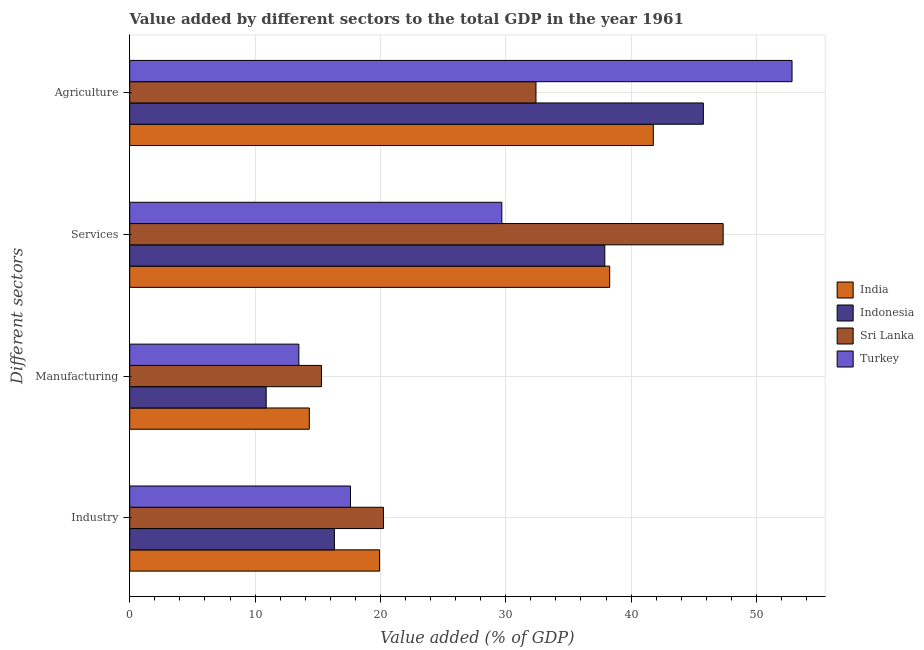Are the number of bars per tick equal to the number of legend labels?
Make the answer very short. Yes. How many bars are there on the 1st tick from the top?
Keep it short and to the point. 4. What is the label of the 4th group of bars from the top?
Your answer should be very brief. Industry. What is the value added by agricultural sector in Turkey?
Your answer should be very brief. 52.84. Across all countries, what is the maximum value added by industrial sector?
Offer a very short reply. 20.24. Across all countries, what is the minimum value added by services sector?
Your answer should be very brief. 29.69. In which country was the value added by manufacturing sector maximum?
Your response must be concise. Sri Lanka. In which country was the value added by agricultural sector minimum?
Provide a short and direct response. Sri Lanka. What is the total value added by services sector in the graph?
Your answer should be very brief. 153.23. What is the difference between the value added by services sector in Indonesia and that in India?
Provide a succinct answer. -0.39. What is the difference between the value added by manufacturing sector in Sri Lanka and the value added by industrial sector in India?
Keep it short and to the point. -4.64. What is the average value added by manufacturing sector per country?
Your response must be concise. 13.5. What is the difference between the value added by manufacturing sector and value added by services sector in India?
Make the answer very short. -23.96. What is the ratio of the value added by industrial sector in Indonesia to that in Turkey?
Offer a very short reply. 0.93. Is the value added by manufacturing sector in Turkey less than that in India?
Give a very brief answer. Yes. Is the difference between the value added by agricultural sector in Indonesia and India greater than the difference between the value added by industrial sector in Indonesia and India?
Ensure brevity in your answer.  Yes. What is the difference between the highest and the second highest value added by services sector?
Your answer should be compact. 9.05. What is the difference between the highest and the lowest value added by industrial sector?
Your answer should be very brief. 3.91. Is the sum of the value added by services sector in Turkey and Indonesia greater than the maximum value added by agricultural sector across all countries?
Your answer should be compact. Yes. What does the 1st bar from the bottom in Manufacturing represents?
Your answer should be very brief. India. How many countries are there in the graph?
Offer a very short reply. 4. Are the values on the major ticks of X-axis written in scientific E-notation?
Offer a terse response. No. Does the graph contain any zero values?
Make the answer very short. No. Does the graph contain grids?
Provide a short and direct response. Yes. How many legend labels are there?
Make the answer very short. 4. What is the title of the graph?
Your answer should be compact. Value added by different sectors to the total GDP in the year 1961. Does "New Caledonia" appear as one of the legend labels in the graph?
Offer a very short reply. No. What is the label or title of the X-axis?
Provide a succinct answer. Value added (% of GDP). What is the label or title of the Y-axis?
Your answer should be compact. Different sectors. What is the Value added (% of GDP) in India in Industry?
Keep it short and to the point. 19.93. What is the Value added (% of GDP) of Indonesia in Industry?
Your response must be concise. 16.33. What is the Value added (% of GDP) in Sri Lanka in Industry?
Keep it short and to the point. 20.24. What is the Value added (% of GDP) of Turkey in Industry?
Make the answer very short. 17.61. What is the Value added (% of GDP) of India in Manufacturing?
Your answer should be very brief. 14.33. What is the Value added (% of GDP) of Indonesia in Manufacturing?
Make the answer very short. 10.89. What is the Value added (% of GDP) of Sri Lanka in Manufacturing?
Provide a succinct answer. 15.3. What is the Value added (% of GDP) of Turkey in Manufacturing?
Make the answer very short. 13.49. What is the Value added (% of GDP) of India in Services?
Provide a short and direct response. 38.29. What is the Value added (% of GDP) of Indonesia in Services?
Your response must be concise. 37.9. What is the Value added (% of GDP) in Sri Lanka in Services?
Offer a very short reply. 47.35. What is the Value added (% of GDP) of Turkey in Services?
Your answer should be compact. 29.69. What is the Value added (% of GDP) in India in Agriculture?
Provide a succinct answer. 41.77. What is the Value added (% of GDP) in Indonesia in Agriculture?
Provide a succinct answer. 45.77. What is the Value added (% of GDP) of Sri Lanka in Agriculture?
Your answer should be compact. 32.41. What is the Value added (% of GDP) in Turkey in Agriculture?
Provide a short and direct response. 52.84. Across all Different sectors, what is the maximum Value added (% of GDP) of India?
Offer a very short reply. 41.77. Across all Different sectors, what is the maximum Value added (% of GDP) of Indonesia?
Offer a terse response. 45.77. Across all Different sectors, what is the maximum Value added (% of GDP) in Sri Lanka?
Offer a terse response. 47.35. Across all Different sectors, what is the maximum Value added (% of GDP) in Turkey?
Your answer should be very brief. 52.84. Across all Different sectors, what is the minimum Value added (% of GDP) in India?
Provide a short and direct response. 14.33. Across all Different sectors, what is the minimum Value added (% of GDP) in Indonesia?
Your answer should be very brief. 10.89. Across all Different sectors, what is the minimum Value added (% of GDP) of Sri Lanka?
Your answer should be compact. 15.3. Across all Different sectors, what is the minimum Value added (% of GDP) in Turkey?
Keep it short and to the point. 13.49. What is the total Value added (% of GDP) of India in the graph?
Ensure brevity in your answer.  114.33. What is the total Value added (% of GDP) of Indonesia in the graph?
Provide a short and direct response. 110.89. What is the total Value added (% of GDP) of Sri Lanka in the graph?
Offer a very short reply. 115.3. What is the total Value added (% of GDP) of Turkey in the graph?
Provide a short and direct response. 113.64. What is the difference between the Value added (% of GDP) of India in Industry and that in Manufacturing?
Make the answer very short. 5.61. What is the difference between the Value added (% of GDP) in Indonesia in Industry and that in Manufacturing?
Your answer should be very brief. 5.44. What is the difference between the Value added (% of GDP) of Sri Lanka in Industry and that in Manufacturing?
Your response must be concise. 4.95. What is the difference between the Value added (% of GDP) in Turkey in Industry and that in Manufacturing?
Offer a terse response. 4.12. What is the difference between the Value added (% of GDP) of India in Industry and that in Services?
Your answer should be compact. -18.36. What is the difference between the Value added (% of GDP) of Indonesia in Industry and that in Services?
Provide a succinct answer. -21.57. What is the difference between the Value added (% of GDP) in Sri Lanka in Industry and that in Services?
Offer a very short reply. -27.1. What is the difference between the Value added (% of GDP) in Turkey in Industry and that in Services?
Offer a terse response. -12.07. What is the difference between the Value added (% of GDP) in India in Industry and that in Agriculture?
Provide a succinct answer. -21.84. What is the difference between the Value added (% of GDP) of Indonesia in Industry and that in Agriculture?
Make the answer very short. -29.44. What is the difference between the Value added (% of GDP) of Sri Lanka in Industry and that in Agriculture?
Your answer should be very brief. -12.17. What is the difference between the Value added (% of GDP) in Turkey in Industry and that in Agriculture?
Your response must be concise. -35.23. What is the difference between the Value added (% of GDP) of India in Manufacturing and that in Services?
Your answer should be very brief. -23.96. What is the difference between the Value added (% of GDP) in Indonesia in Manufacturing and that in Services?
Provide a short and direct response. -27.02. What is the difference between the Value added (% of GDP) in Sri Lanka in Manufacturing and that in Services?
Offer a terse response. -32.05. What is the difference between the Value added (% of GDP) of Turkey in Manufacturing and that in Services?
Your answer should be compact. -16.19. What is the difference between the Value added (% of GDP) in India in Manufacturing and that in Agriculture?
Your answer should be very brief. -27.45. What is the difference between the Value added (% of GDP) in Indonesia in Manufacturing and that in Agriculture?
Provide a succinct answer. -34.88. What is the difference between the Value added (% of GDP) of Sri Lanka in Manufacturing and that in Agriculture?
Make the answer very short. -17.11. What is the difference between the Value added (% of GDP) in Turkey in Manufacturing and that in Agriculture?
Ensure brevity in your answer.  -39.35. What is the difference between the Value added (% of GDP) of India in Services and that in Agriculture?
Your response must be concise. -3.48. What is the difference between the Value added (% of GDP) in Indonesia in Services and that in Agriculture?
Keep it short and to the point. -7.86. What is the difference between the Value added (% of GDP) of Sri Lanka in Services and that in Agriculture?
Your response must be concise. 14.93. What is the difference between the Value added (% of GDP) of Turkey in Services and that in Agriculture?
Keep it short and to the point. -23.15. What is the difference between the Value added (% of GDP) of India in Industry and the Value added (% of GDP) of Indonesia in Manufacturing?
Make the answer very short. 9.05. What is the difference between the Value added (% of GDP) of India in Industry and the Value added (% of GDP) of Sri Lanka in Manufacturing?
Keep it short and to the point. 4.64. What is the difference between the Value added (% of GDP) of India in Industry and the Value added (% of GDP) of Turkey in Manufacturing?
Your answer should be very brief. 6.44. What is the difference between the Value added (% of GDP) of Indonesia in Industry and the Value added (% of GDP) of Sri Lanka in Manufacturing?
Provide a short and direct response. 1.03. What is the difference between the Value added (% of GDP) in Indonesia in Industry and the Value added (% of GDP) in Turkey in Manufacturing?
Provide a succinct answer. 2.84. What is the difference between the Value added (% of GDP) of Sri Lanka in Industry and the Value added (% of GDP) of Turkey in Manufacturing?
Offer a terse response. 6.75. What is the difference between the Value added (% of GDP) of India in Industry and the Value added (% of GDP) of Indonesia in Services?
Provide a succinct answer. -17.97. What is the difference between the Value added (% of GDP) of India in Industry and the Value added (% of GDP) of Sri Lanka in Services?
Make the answer very short. -27.41. What is the difference between the Value added (% of GDP) in India in Industry and the Value added (% of GDP) in Turkey in Services?
Offer a very short reply. -9.75. What is the difference between the Value added (% of GDP) of Indonesia in Industry and the Value added (% of GDP) of Sri Lanka in Services?
Your answer should be compact. -31.02. What is the difference between the Value added (% of GDP) of Indonesia in Industry and the Value added (% of GDP) of Turkey in Services?
Ensure brevity in your answer.  -13.36. What is the difference between the Value added (% of GDP) of Sri Lanka in Industry and the Value added (% of GDP) of Turkey in Services?
Offer a terse response. -9.44. What is the difference between the Value added (% of GDP) in India in Industry and the Value added (% of GDP) in Indonesia in Agriculture?
Give a very brief answer. -25.83. What is the difference between the Value added (% of GDP) in India in Industry and the Value added (% of GDP) in Sri Lanka in Agriculture?
Make the answer very short. -12.48. What is the difference between the Value added (% of GDP) in India in Industry and the Value added (% of GDP) in Turkey in Agriculture?
Offer a terse response. -32.91. What is the difference between the Value added (% of GDP) in Indonesia in Industry and the Value added (% of GDP) in Sri Lanka in Agriculture?
Give a very brief answer. -16.08. What is the difference between the Value added (% of GDP) of Indonesia in Industry and the Value added (% of GDP) of Turkey in Agriculture?
Provide a succinct answer. -36.51. What is the difference between the Value added (% of GDP) of Sri Lanka in Industry and the Value added (% of GDP) of Turkey in Agriculture?
Your response must be concise. -32.6. What is the difference between the Value added (% of GDP) of India in Manufacturing and the Value added (% of GDP) of Indonesia in Services?
Offer a very short reply. -23.58. What is the difference between the Value added (% of GDP) of India in Manufacturing and the Value added (% of GDP) of Sri Lanka in Services?
Your answer should be very brief. -33.02. What is the difference between the Value added (% of GDP) of India in Manufacturing and the Value added (% of GDP) of Turkey in Services?
Offer a very short reply. -15.36. What is the difference between the Value added (% of GDP) in Indonesia in Manufacturing and the Value added (% of GDP) in Sri Lanka in Services?
Your response must be concise. -36.46. What is the difference between the Value added (% of GDP) of Indonesia in Manufacturing and the Value added (% of GDP) of Turkey in Services?
Offer a very short reply. -18.8. What is the difference between the Value added (% of GDP) of Sri Lanka in Manufacturing and the Value added (% of GDP) of Turkey in Services?
Your answer should be very brief. -14.39. What is the difference between the Value added (% of GDP) of India in Manufacturing and the Value added (% of GDP) of Indonesia in Agriculture?
Give a very brief answer. -31.44. What is the difference between the Value added (% of GDP) of India in Manufacturing and the Value added (% of GDP) of Sri Lanka in Agriculture?
Offer a terse response. -18.08. What is the difference between the Value added (% of GDP) in India in Manufacturing and the Value added (% of GDP) in Turkey in Agriculture?
Offer a very short reply. -38.51. What is the difference between the Value added (% of GDP) in Indonesia in Manufacturing and the Value added (% of GDP) in Sri Lanka in Agriculture?
Your answer should be very brief. -21.52. What is the difference between the Value added (% of GDP) of Indonesia in Manufacturing and the Value added (% of GDP) of Turkey in Agriculture?
Offer a terse response. -41.95. What is the difference between the Value added (% of GDP) of Sri Lanka in Manufacturing and the Value added (% of GDP) of Turkey in Agriculture?
Provide a succinct answer. -37.54. What is the difference between the Value added (% of GDP) of India in Services and the Value added (% of GDP) of Indonesia in Agriculture?
Offer a very short reply. -7.47. What is the difference between the Value added (% of GDP) of India in Services and the Value added (% of GDP) of Sri Lanka in Agriculture?
Your answer should be very brief. 5.88. What is the difference between the Value added (% of GDP) of India in Services and the Value added (% of GDP) of Turkey in Agriculture?
Provide a succinct answer. -14.55. What is the difference between the Value added (% of GDP) in Indonesia in Services and the Value added (% of GDP) in Sri Lanka in Agriculture?
Your answer should be compact. 5.49. What is the difference between the Value added (% of GDP) of Indonesia in Services and the Value added (% of GDP) of Turkey in Agriculture?
Ensure brevity in your answer.  -14.94. What is the difference between the Value added (% of GDP) of Sri Lanka in Services and the Value added (% of GDP) of Turkey in Agriculture?
Offer a terse response. -5.5. What is the average Value added (% of GDP) in India per Different sectors?
Keep it short and to the point. 28.58. What is the average Value added (% of GDP) of Indonesia per Different sectors?
Make the answer very short. 27.72. What is the average Value added (% of GDP) of Sri Lanka per Different sectors?
Give a very brief answer. 28.82. What is the average Value added (% of GDP) in Turkey per Different sectors?
Keep it short and to the point. 28.41. What is the difference between the Value added (% of GDP) of India and Value added (% of GDP) of Indonesia in Industry?
Your answer should be very brief. 3.6. What is the difference between the Value added (% of GDP) of India and Value added (% of GDP) of Sri Lanka in Industry?
Your answer should be compact. -0.31. What is the difference between the Value added (% of GDP) in India and Value added (% of GDP) in Turkey in Industry?
Give a very brief answer. 2.32. What is the difference between the Value added (% of GDP) of Indonesia and Value added (% of GDP) of Sri Lanka in Industry?
Offer a very short reply. -3.91. What is the difference between the Value added (% of GDP) in Indonesia and Value added (% of GDP) in Turkey in Industry?
Your answer should be very brief. -1.28. What is the difference between the Value added (% of GDP) of Sri Lanka and Value added (% of GDP) of Turkey in Industry?
Your answer should be compact. 2.63. What is the difference between the Value added (% of GDP) in India and Value added (% of GDP) in Indonesia in Manufacturing?
Ensure brevity in your answer.  3.44. What is the difference between the Value added (% of GDP) of India and Value added (% of GDP) of Sri Lanka in Manufacturing?
Give a very brief answer. -0.97. What is the difference between the Value added (% of GDP) in India and Value added (% of GDP) in Turkey in Manufacturing?
Ensure brevity in your answer.  0.83. What is the difference between the Value added (% of GDP) in Indonesia and Value added (% of GDP) in Sri Lanka in Manufacturing?
Offer a very short reply. -4.41. What is the difference between the Value added (% of GDP) in Indonesia and Value added (% of GDP) in Turkey in Manufacturing?
Your answer should be compact. -2.61. What is the difference between the Value added (% of GDP) in Sri Lanka and Value added (% of GDP) in Turkey in Manufacturing?
Your answer should be very brief. 1.8. What is the difference between the Value added (% of GDP) in India and Value added (% of GDP) in Indonesia in Services?
Give a very brief answer. 0.39. What is the difference between the Value added (% of GDP) in India and Value added (% of GDP) in Sri Lanka in Services?
Ensure brevity in your answer.  -9.05. What is the difference between the Value added (% of GDP) of India and Value added (% of GDP) of Turkey in Services?
Provide a short and direct response. 8.61. What is the difference between the Value added (% of GDP) in Indonesia and Value added (% of GDP) in Sri Lanka in Services?
Provide a short and direct response. -9.44. What is the difference between the Value added (% of GDP) of Indonesia and Value added (% of GDP) of Turkey in Services?
Your answer should be compact. 8.22. What is the difference between the Value added (% of GDP) in Sri Lanka and Value added (% of GDP) in Turkey in Services?
Keep it short and to the point. 17.66. What is the difference between the Value added (% of GDP) in India and Value added (% of GDP) in Indonesia in Agriculture?
Your answer should be very brief. -3.99. What is the difference between the Value added (% of GDP) of India and Value added (% of GDP) of Sri Lanka in Agriculture?
Keep it short and to the point. 9.36. What is the difference between the Value added (% of GDP) of India and Value added (% of GDP) of Turkey in Agriculture?
Provide a short and direct response. -11.07. What is the difference between the Value added (% of GDP) of Indonesia and Value added (% of GDP) of Sri Lanka in Agriculture?
Keep it short and to the point. 13.35. What is the difference between the Value added (% of GDP) of Indonesia and Value added (% of GDP) of Turkey in Agriculture?
Give a very brief answer. -7.07. What is the difference between the Value added (% of GDP) of Sri Lanka and Value added (% of GDP) of Turkey in Agriculture?
Your answer should be very brief. -20.43. What is the ratio of the Value added (% of GDP) of India in Industry to that in Manufacturing?
Make the answer very short. 1.39. What is the ratio of the Value added (% of GDP) of Sri Lanka in Industry to that in Manufacturing?
Ensure brevity in your answer.  1.32. What is the ratio of the Value added (% of GDP) in Turkey in Industry to that in Manufacturing?
Offer a terse response. 1.31. What is the ratio of the Value added (% of GDP) of India in Industry to that in Services?
Keep it short and to the point. 0.52. What is the ratio of the Value added (% of GDP) in Indonesia in Industry to that in Services?
Offer a very short reply. 0.43. What is the ratio of the Value added (% of GDP) of Sri Lanka in Industry to that in Services?
Ensure brevity in your answer.  0.43. What is the ratio of the Value added (% of GDP) in Turkey in Industry to that in Services?
Ensure brevity in your answer.  0.59. What is the ratio of the Value added (% of GDP) of India in Industry to that in Agriculture?
Provide a succinct answer. 0.48. What is the ratio of the Value added (% of GDP) in Indonesia in Industry to that in Agriculture?
Provide a short and direct response. 0.36. What is the ratio of the Value added (% of GDP) in Sri Lanka in Industry to that in Agriculture?
Provide a succinct answer. 0.62. What is the ratio of the Value added (% of GDP) in India in Manufacturing to that in Services?
Make the answer very short. 0.37. What is the ratio of the Value added (% of GDP) in Indonesia in Manufacturing to that in Services?
Offer a very short reply. 0.29. What is the ratio of the Value added (% of GDP) of Sri Lanka in Manufacturing to that in Services?
Provide a short and direct response. 0.32. What is the ratio of the Value added (% of GDP) in Turkey in Manufacturing to that in Services?
Provide a short and direct response. 0.45. What is the ratio of the Value added (% of GDP) in India in Manufacturing to that in Agriculture?
Provide a succinct answer. 0.34. What is the ratio of the Value added (% of GDP) in Indonesia in Manufacturing to that in Agriculture?
Provide a succinct answer. 0.24. What is the ratio of the Value added (% of GDP) of Sri Lanka in Manufacturing to that in Agriculture?
Offer a terse response. 0.47. What is the ratio of the Value added (% of GDP) in Turkey in Manufacturing to that in Agriculture?
Provide a short and direct response. 0.26. What is the ratio of the Value added (% of GDP) in Indonesia in Services to that in Agriculture?
Offer a terse response. 0.83. What is the ratio of the Value added (% of GDP) of Sri Lanka in Services to that in Agriculture?
Keep it short and to the point. 1.46. What is the ratio of the Value added (% of GDP) in Turkey in Services to that in Agriculture?
Your answer should be very brief. 0.56. What is the difference between the highest and the second highest Value added (% of GDP) in India?
Ensure brevity in your answer.  3.48. What is the difference between the highest and the second highest Value added (% of GDP) of Indonesia?
Provide a short and direct response. 7.86. What is the difference between the highest and the second highest Value added (% of GDP) in Sri Lanka?
Make the answer very short. 14.93. What is the difference between the highest and the second highest Value added (% of GDP) of Turkey?
Ensure brevity in your answer.  23.15. What is the difference between the highest and the lowest Value added (% of GDP) in India?
Your answer should be very brief. 27.45. What is the difference between the highest and the lowest Value added (% of GDP) in Indonesia?
Keep it short and to the point. 34.88. What is the difference between the highest and the lowest Value added (% of GDP) in Sri Lanka?
Offer a terse response. 32.05. What is the difference between the highest and the lowest Value added (% of GDP) in Turkey?
Provide a short and direct response. 39.35. 